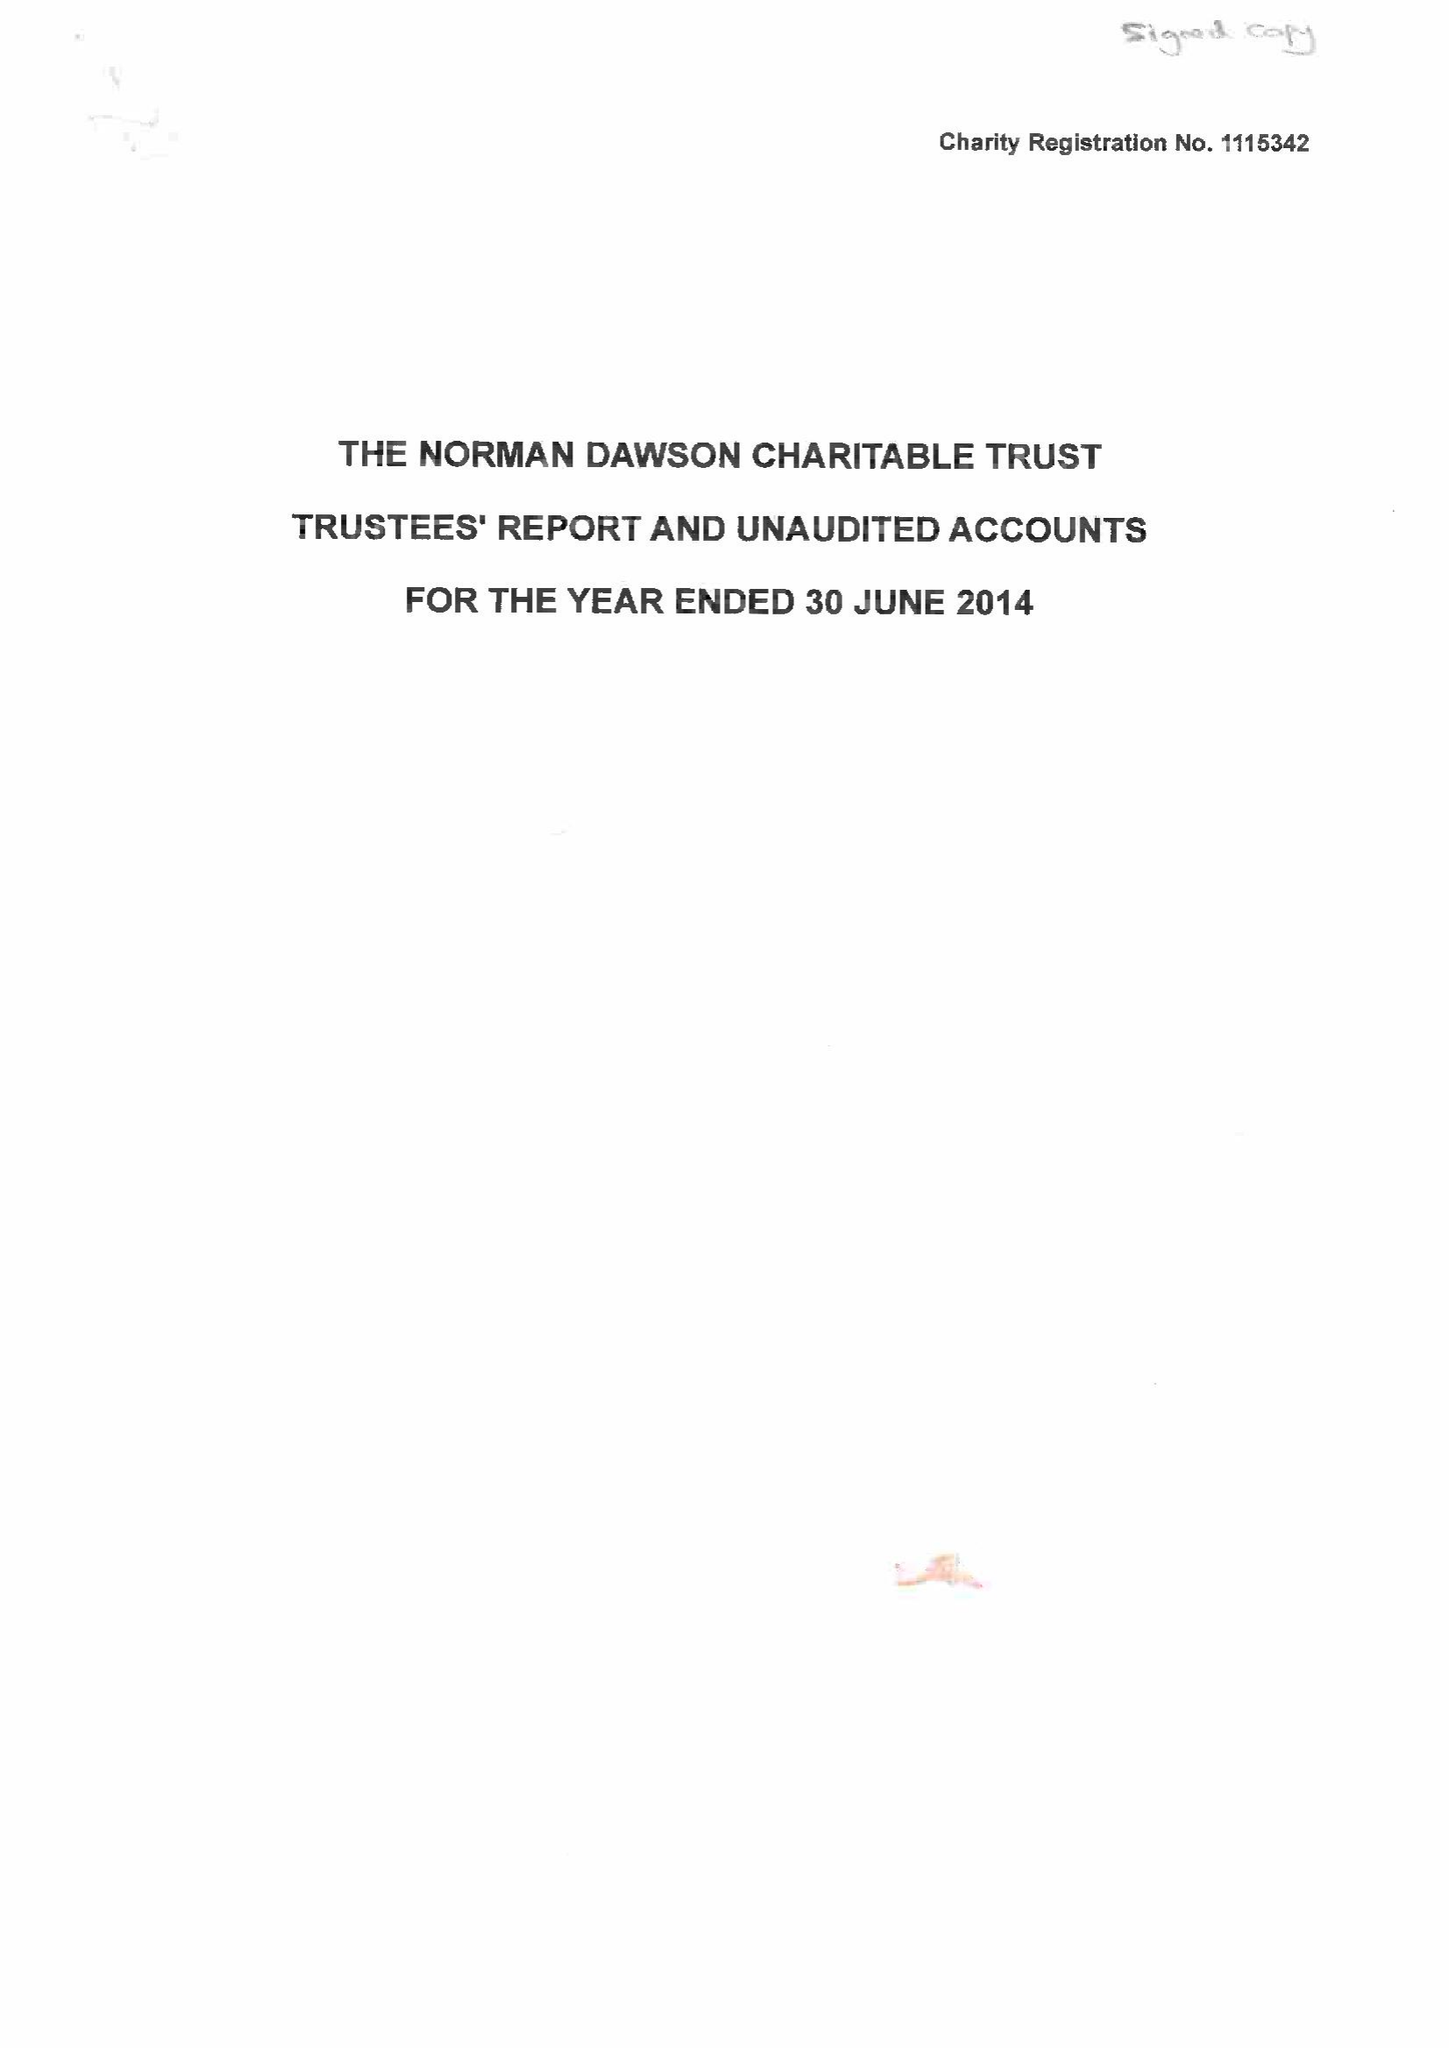What is the value for the charity_number?
Answer the question using a single word or phrase. 1115342 